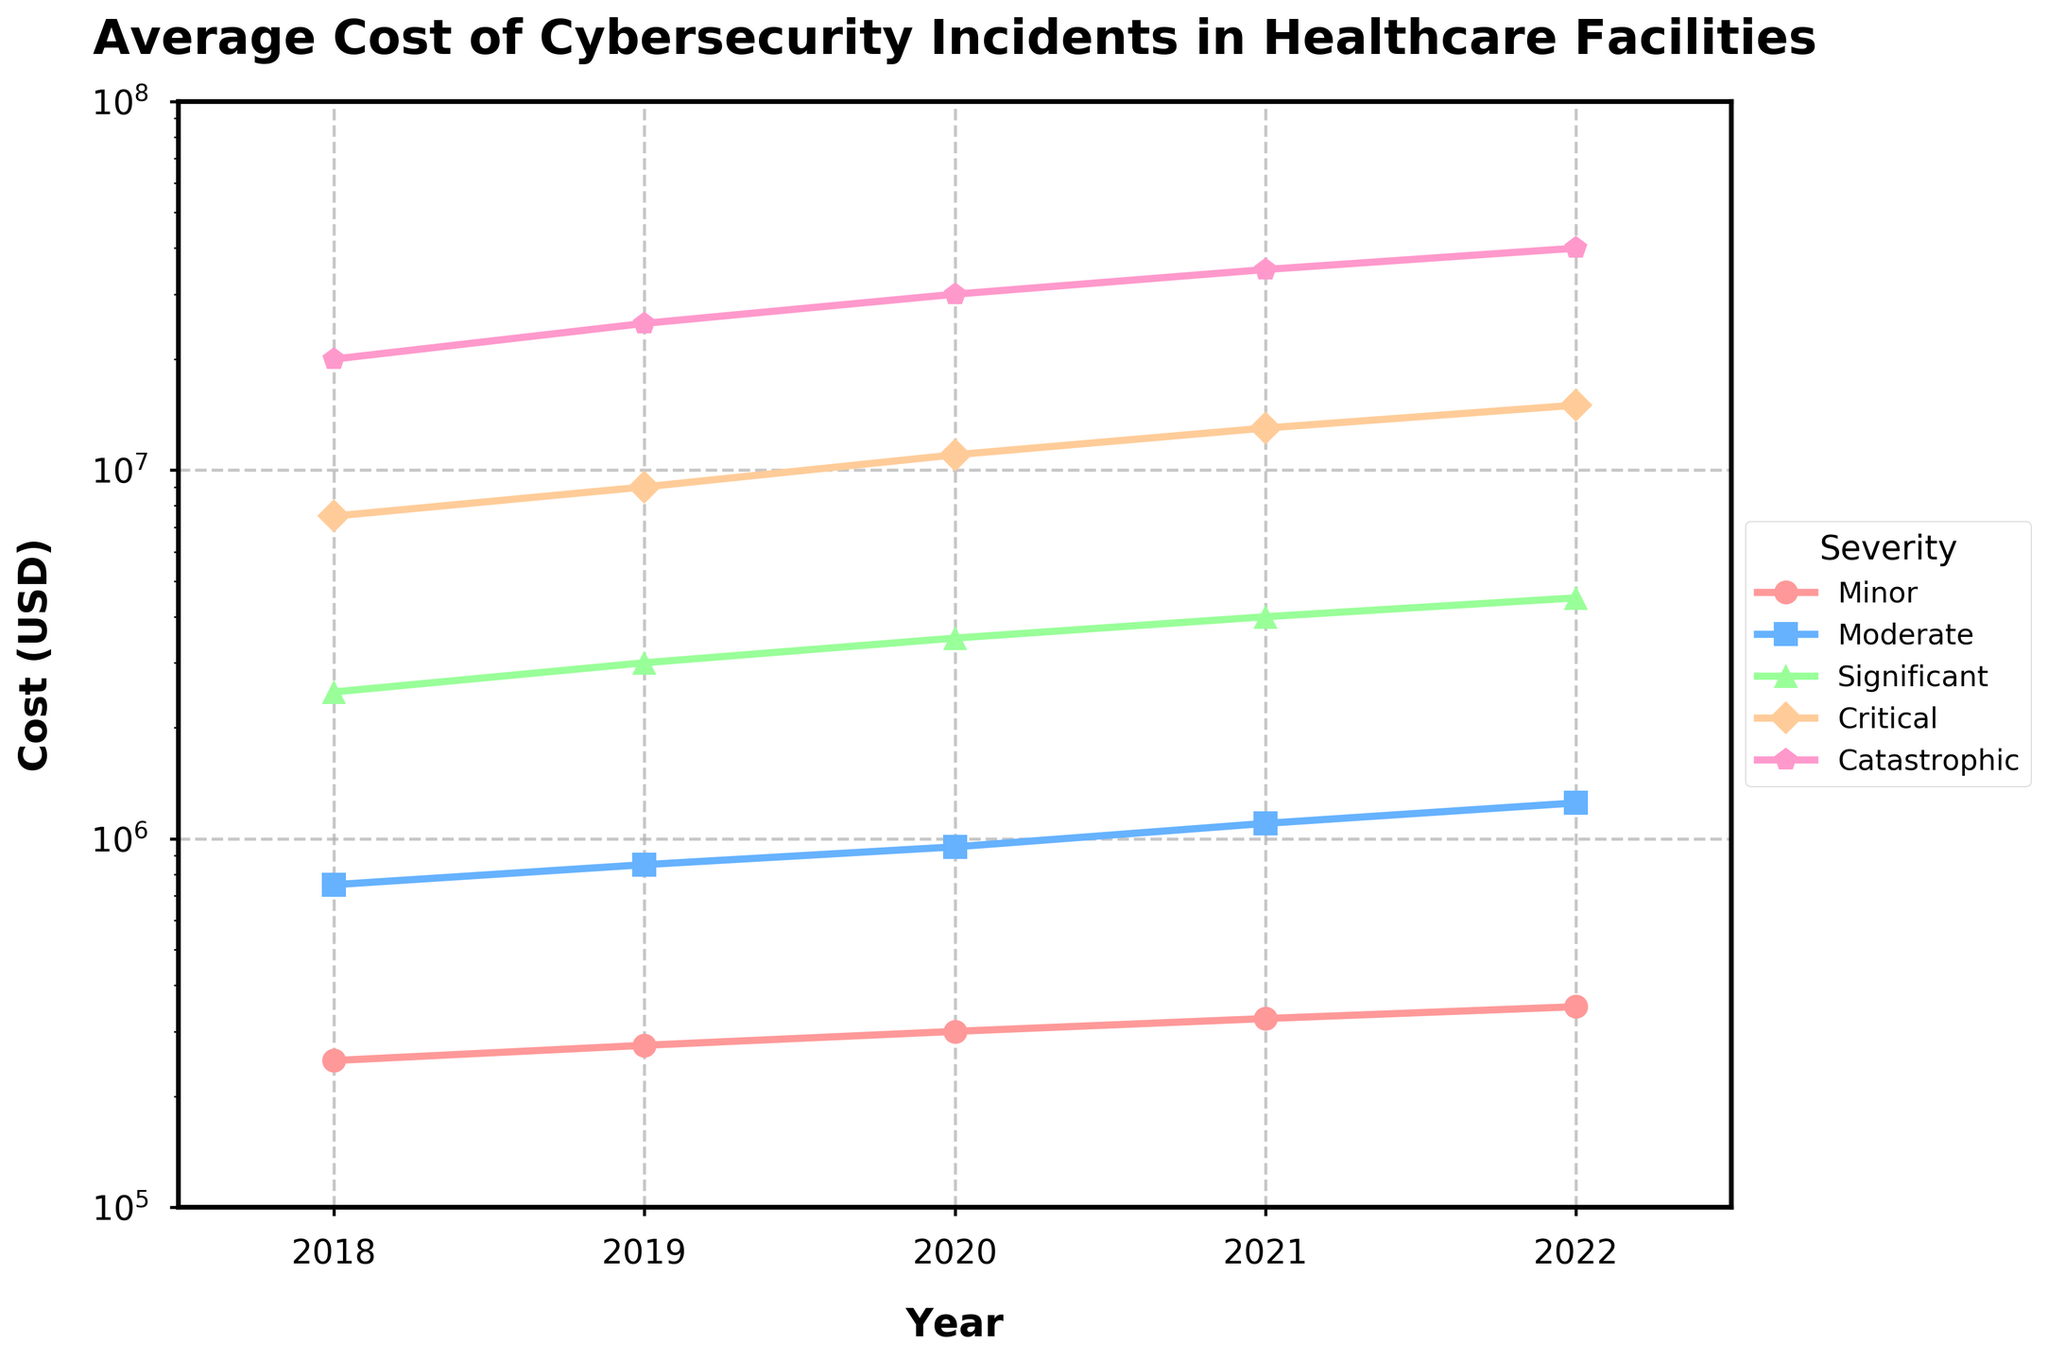What's the percentage increase in the average cost of catastrophic incidents from 2018 to 2022? First, note the cost in 2018, which is $20,000,000, and the cost in 2022, which is $40,000,000. The percentage increase is calculated as \(\frac{(40,000,000 - 20,000,000)}{20,000,000} \times 100\). This equals \(\frac{20,000,000}{20,000,000} \times 100 = 100\%\).
Answer: 100% What's the difference in cost between moderate and minor incidents in 2021? Find the cost of moderate incidents in 2021 which is $1,100,000, and the cost of minor incidents, which is $325,000. The difference is $1,100,000 - $325,000 = $775,000.
Answer: $775,000 Which year experienced the highest average cost for critical incidents? Look at the critical incidents data across the years and identify the highest value. The highest cost is $15,000,000 in 2022.
Answer: 2022 By what factor did the average cost of significant incidents increase from 2018 to 2022? Note the average cost of significant incidents in 2018, which is $2,500,000, and in 2022, which is $4,500,000. The factor increase is calculated as \( \frac{4,500,000}{2,500,000} \). This equals 1.8.
Answer: 1.8 How does the average cost of minor incidents compare to moderate incidents throughout the years? For each year, compare the average cost of minor incidents to moderate incidents:
2018: $250,000 < $750,000
2019: $275,000 < $850,000
2020: $300,000 < $950,000
2021: $325,000 < $1,100,000
2022: $350,000 < $1,250,000
In all these years, the cost of minor incidents is always less than moderate incidents.
Answer: Minor incidents cost less in every year What is the overall trend in the cost of cybersecurity incidents across all severity levels over the years? Observe each line representing different severity levels. It can be seen that the cost for each severity level increases consistently from 2018 to 2022.
Answer: Increasing What color is used to represent 'Significant' severity in the plot? Identify the color associated with the 'Significant' severity based on the legend in the plot. The color is often matched with the line graph, which is 'green'.
Answer: Green What is the average increase per year in the cost of moderate incidents from 2018 to 2022? Subtract the 2018 value from the 2022 value, then divide by the number of years between them (4). The average increase per year is \((1,250,000 - 750,000) / 4 = 500,000 / 4 = 125,000\).
Answer: $125,000 Between which two consecutive years do catastrophic incidents see the highest absolute increase in costs? Calculate the absolute increase between consecutive years:
2019: $25,000,000 - $20,000,000 = $5,000,000
2020: $30,000,000 - $25,000,000 = $5,000,000
2021: $35,000,000 - $30,000,000 = $5,000,000
2022: $40,000,000 - $35,000,000 = $5,000,000
All have the same increase of $5,000,000.
Answer: Each year has the same increase 